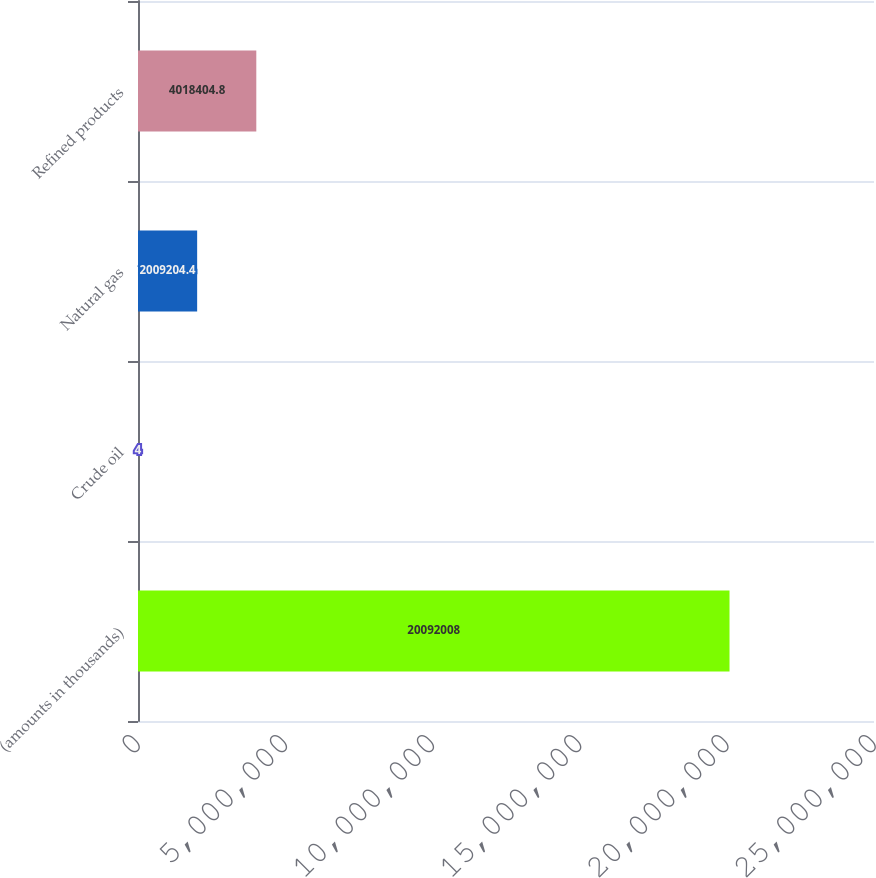Convert chart. <chart><loc_0><loc_0><loc_500><loc_500><bar_chart><fcel>(amounts in thousands)<fcel>Crude oil<fcel>Natural gas<fcel>Refined products<nl><fcel>2.0092e+07<fcel>4<fcel>2.0092e+06<fcel>4.0184e+06<nl></chart> 